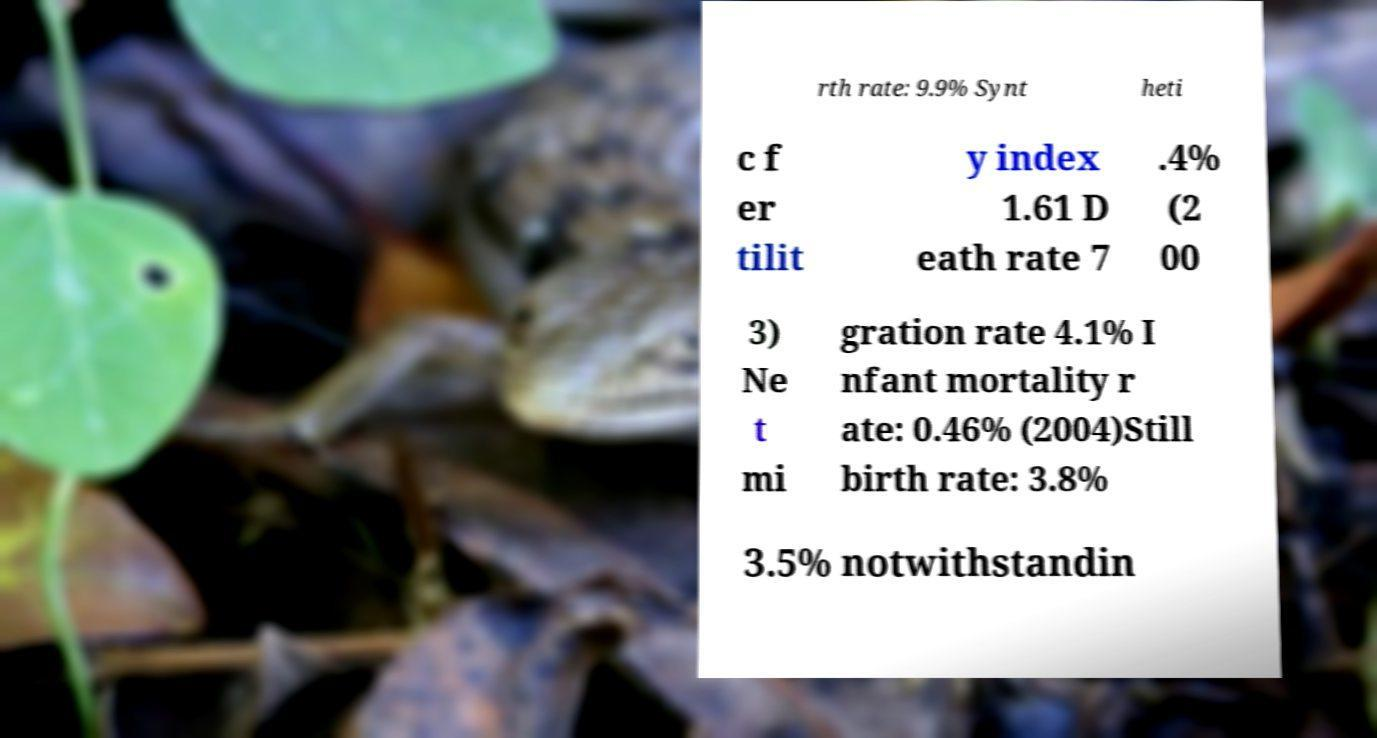Please identify and transcribe the text found in this image. rth rate: 9.9% Synt heti c f er tilit y index 1.61 D eath rate 7 .4% (2 00 3) Ne t mi gration rate 4.1% I nfant mortality r ate: 0.46% (2004)Still birth rate: 3.8% 3.5% notwithstandin 